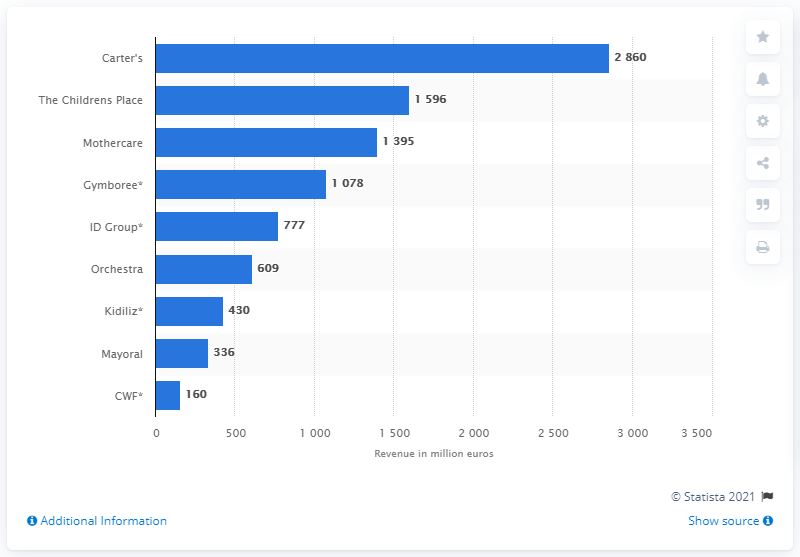Identify some key points in this picture. In 2016, Carter's global revenue was 2,860. In 2016, Carter's was the leading children's clothing retailer in the world. 